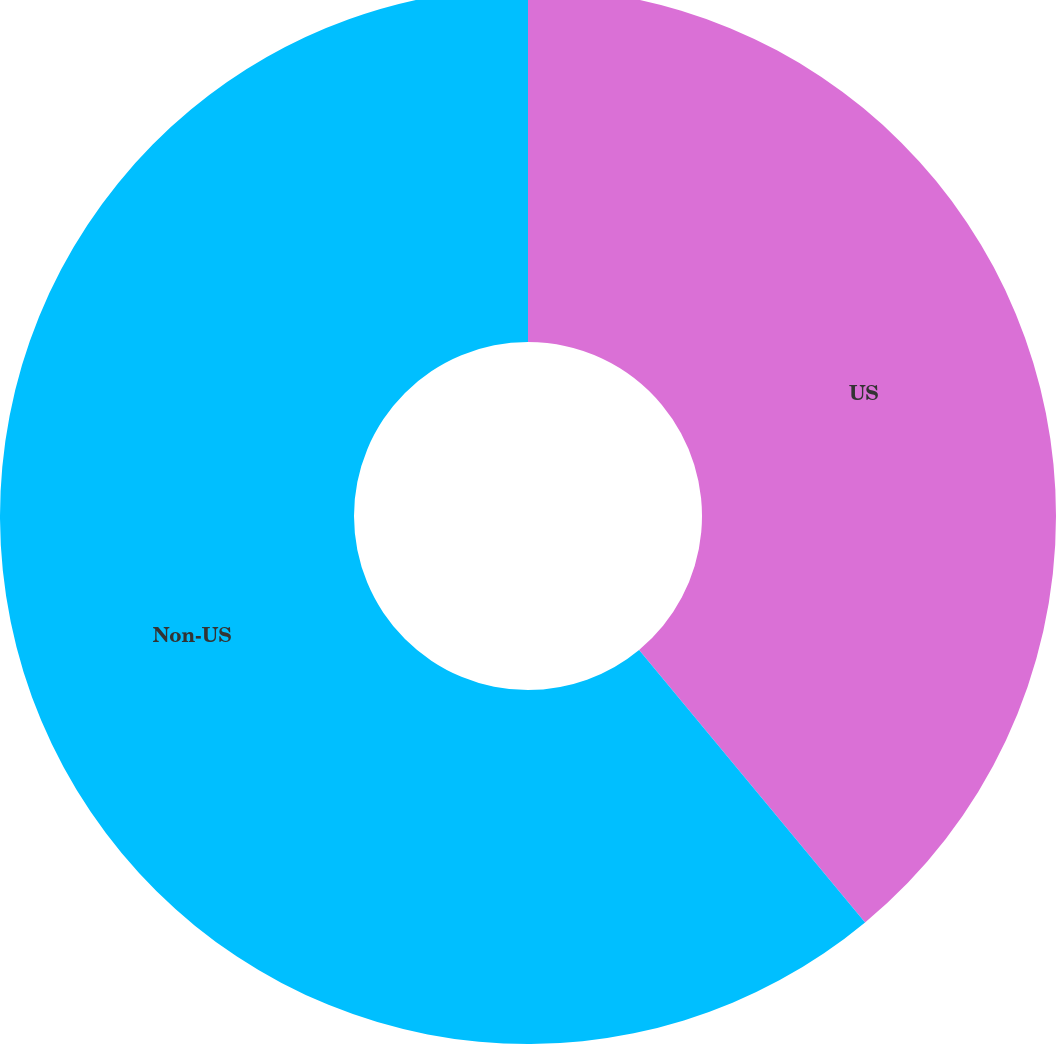Convert chart. <chart><loc_0><loc_0><loc_500><loc_500><pie_chart><fcel>US<fcel>Non-US<nl><fcel>38.98%<fcel>61.02%<nl></chart> 